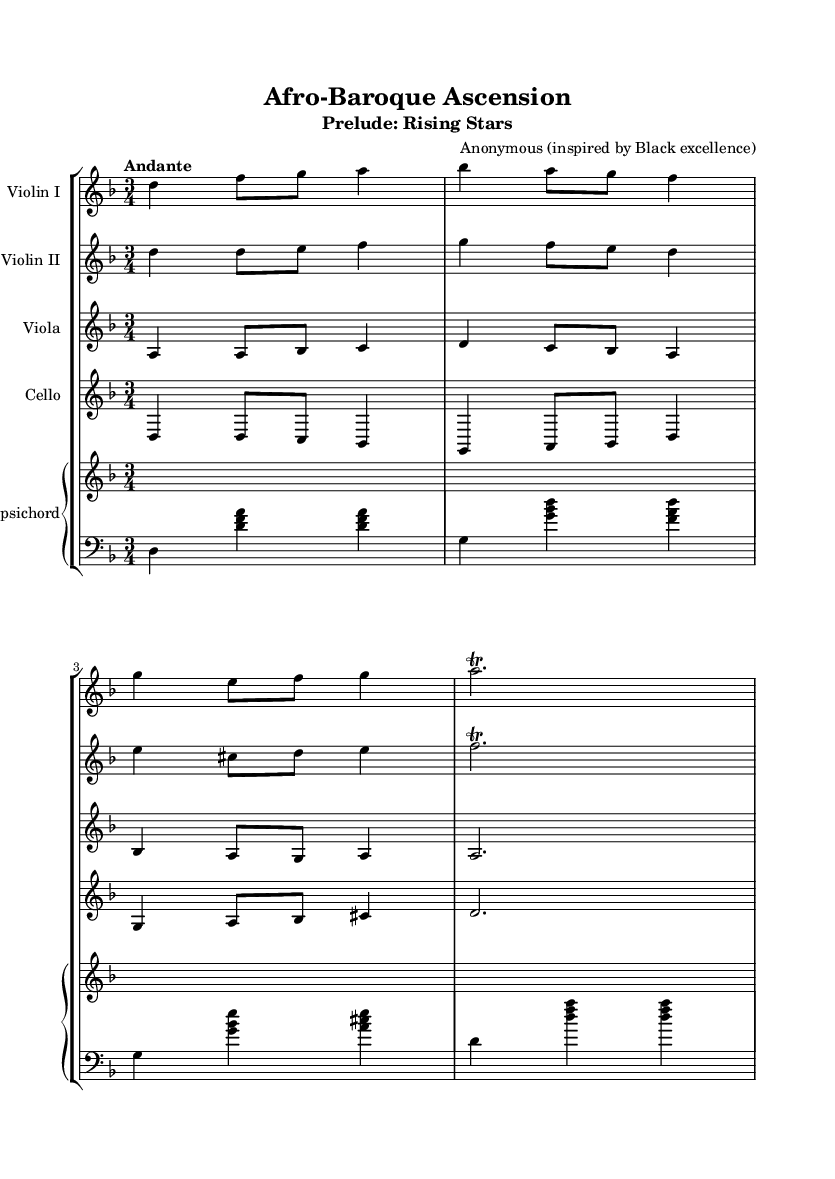What is the key signature of this music? The key signature is D minor, which has one flat (B flat).
Answer: D minor What is the time signature of this music? The time signature is 3/4, indicating three beats per measure.
Answer: 3/4 What is the tempo marking of this piece? The tempo marking is "Andante," which indicates a moderately slow tempo.
Answer: Andante How many instruments are featured in this score? The score features five instruments: two violins, a viola, a cello, and a harpsichord.
Answer: Five What type of composition is this? This composition is labeled as a "Prelude," which typically serves as an introductory piece.
Answer: Prelude Which instrument plays the bass clef? The harpsichord plays the bass clef, as indicated by the clef symbol.
Answer: Harpsichord How many measures are in the violin one part? The violin one part contains a total of eight measures.
Answer: Eight 